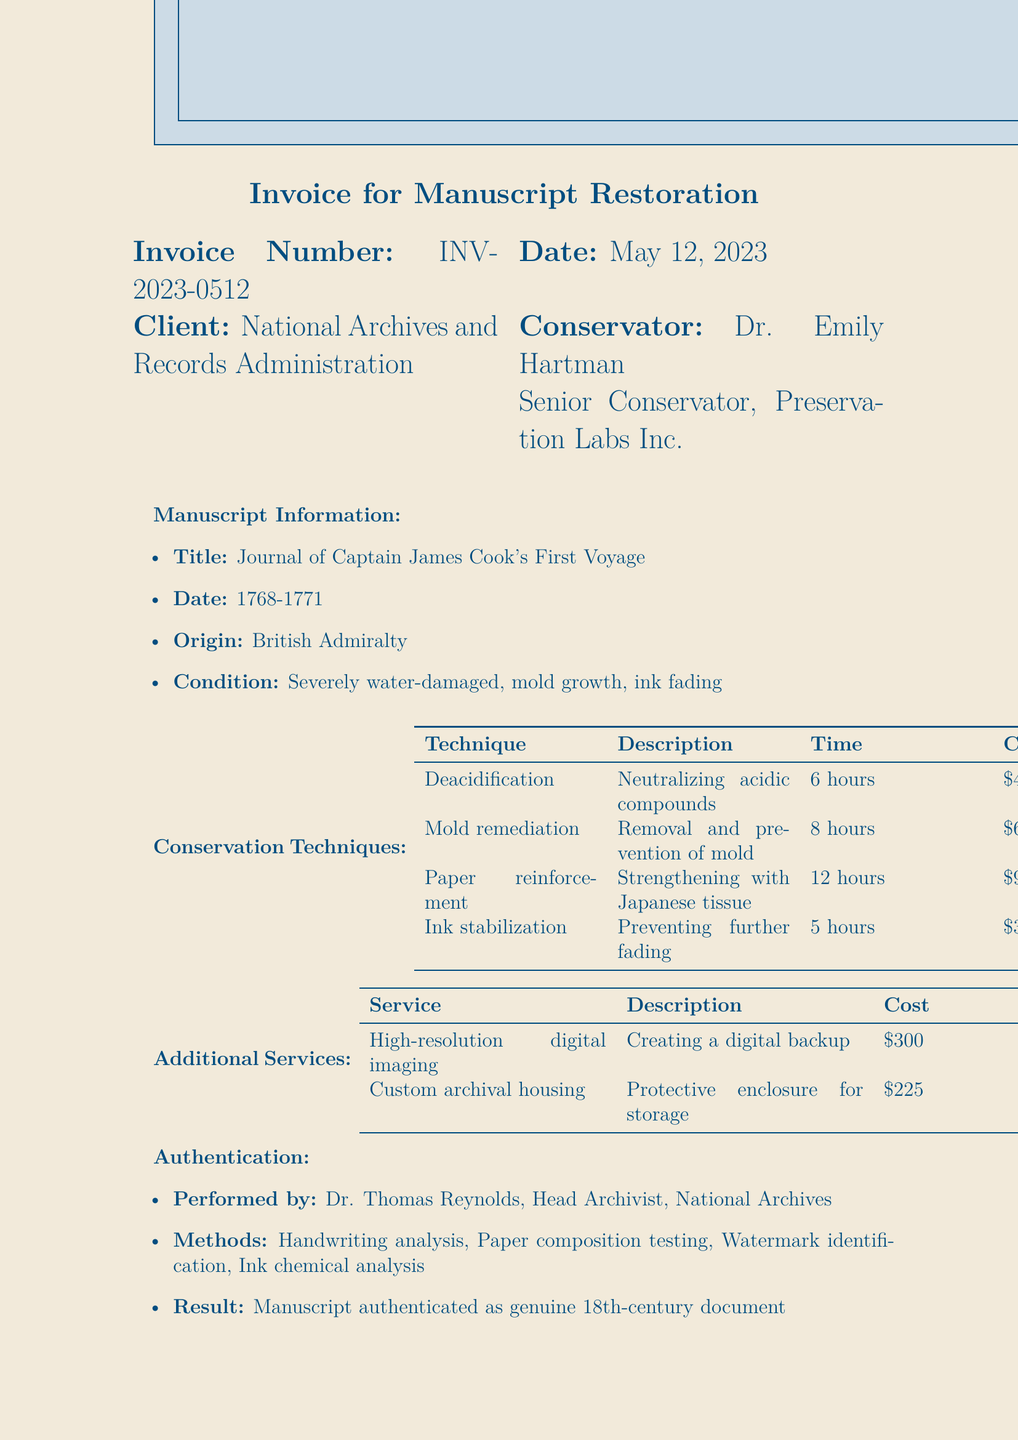What is the invoice number? The invoice number can be found in the invoice details section of the document.
Answer: INV-2023-0512 What is the total cost for the restoration? The total cost is the sum of conservation techniques, additional services, authentication process, tax, and subtotal.
Answer: $3,942 Who is the conservator? The conservator's name is mentioned in the invoice details section.
Answer: Dr. Emily Hartman What date was the manuscript dated? The date of the manuscript is specified in the manuscript information section.
Answer: 1768-1771 How many hours were spent on paper reinforcement? The time spent on paper reinforcement is listed under conservation techniques.
Answer: 12 hours What is the due date for payment? The due date is detailed in the payment terms section of the document.
Answer: June 12, 2023 What materials were used for mold remediation? The materials used for mold remediation are described in the conservation techniques section.
Answer: 70% isopropyl alcohol, HEPA vacuum, UV-C light treatment Who performed the authentication of the manuscript? The person who performed the authentication is noted in the authentication process section.
Answer: Dr. Thomas Reynolds What is the cost of custom archival housing? The cost is mentioned in the additional services section of the document.
Answer: $225 